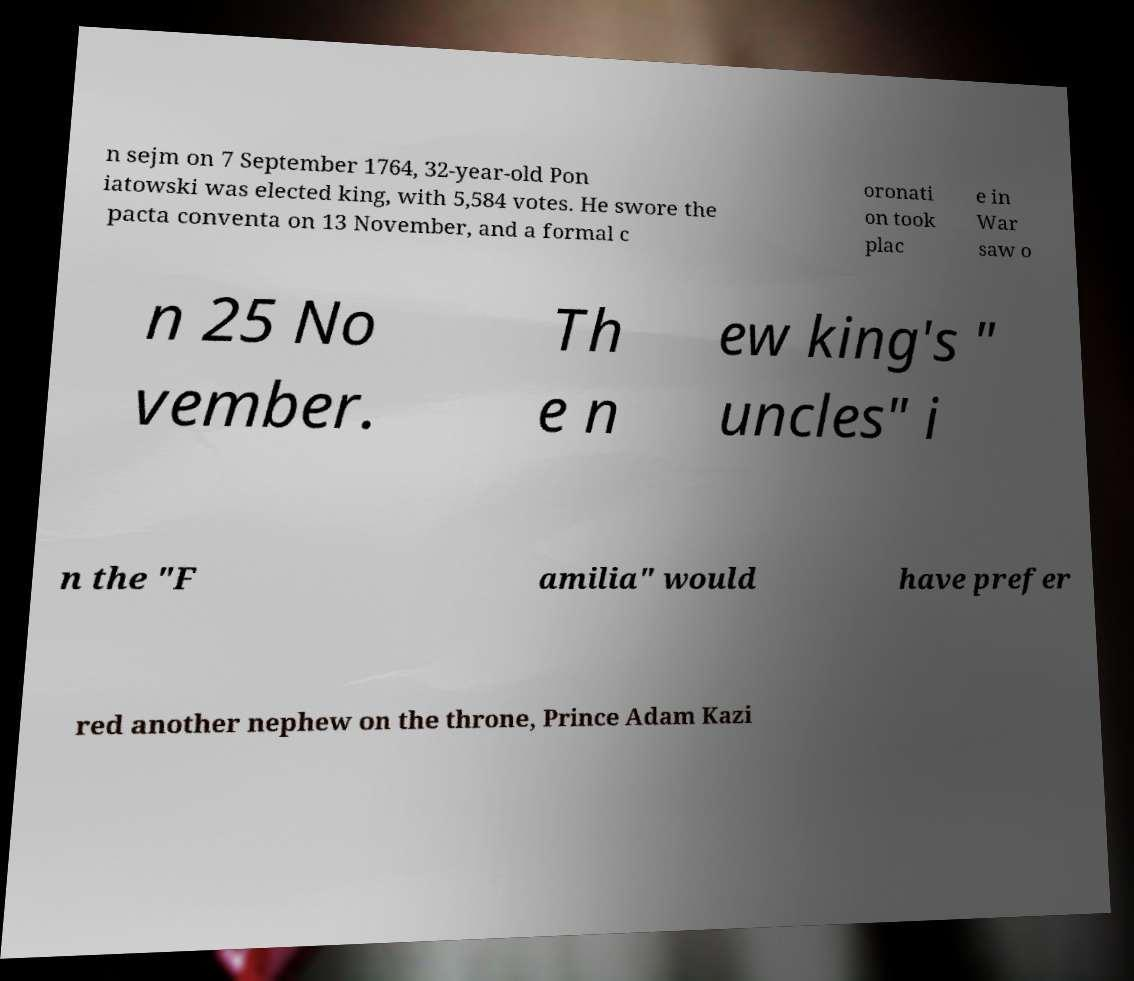Could you extract and type out the text from this image? n sejm on 7 September 1764, 32-year-old Pon iatowski was elected king, with 5,584 votes. He swore the pacta conventa on 13 November, and a formal c oronati on took plac e in War saw o n 25 No vember. Th e n ew king's " uncles" i n the "F amilia" would have prefer red another nephew on the throne, Prince Adam Kazi 